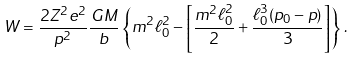<formula> <loc_0><loc_0><loc_500><loc_500>W = \frac { 2 Z ^ { 2 } e ^ { 2 } } { p ^ { 2 } } \frac { G M } { b } \left \{ m ^ { 2 } \ell _ { 0 } ^ { 2 } - \left [ \frac { m ^ { 2 } \ell _ { 0 } ^ { 2 } } { 2 } + \frac { \ell _ { 0 } ^ { 3 } ( p _ { 0 } - p ) } { 3 } \right ] \right \} \, .</formula> 